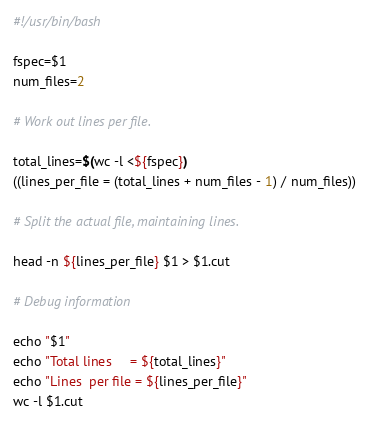<code> <loc_0><loc_0><loc_500><loc_500><_Bash_>#!/usr/bin/bash

fspec=$1
num_files=2

# Work out lines per file.

total_lines=$(wc -l <${fspec})
((lines_per_file = (total_lines + num_files - 1) / num_files))

# Split the actual file, maintaining lines.

head -n ${lines_per_file} $1 > $1.cut

# Debug information

echo "$1"
echo "Total lines     = ${total_lines}"
echo "Lines  per file = ${lines_per_file}"
wc -l $1.cut
</code> 